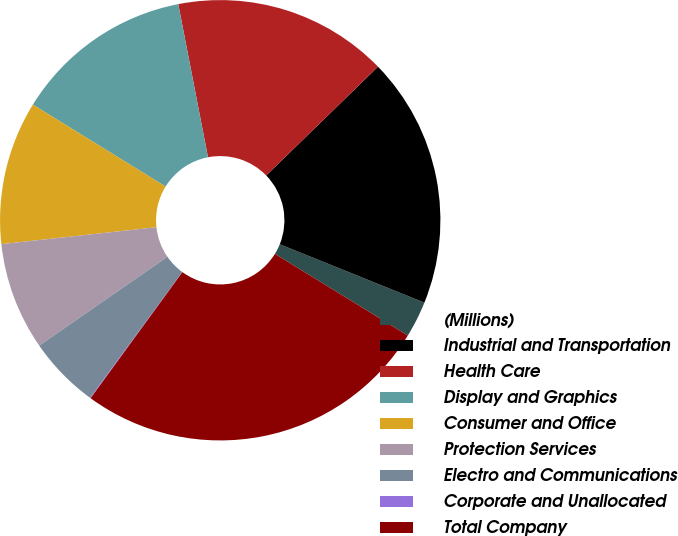<chart> <loc_0><loc_0><loc_500><loc_500><pie_chart><fcel>(Millions)<fcel>Industrial and Transportation<fcel>Health Care<fcel>Display and Graphics<fcel>Consumer and Office<fcel>Protection Services<fcel>Electro and Communications<fcel>Corporate and Unallocated<fcel>Total Company<nl><fcel>2.67%<fcel>18.39%<fcel>15.77%<fcel>13.15%<fcel>10.53%<fcel>7.91%<fcel>5.29%<fcel>0.05%<fcel>26.25%<nl></chart> 